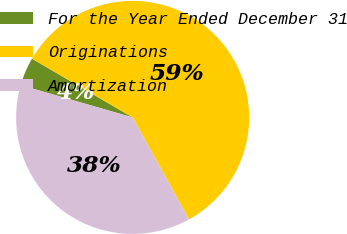<chart> <loc_0><loc_0><loc_500><loc_500><pie_chart><fcel>For the Year Ended December 31<fcel>Originations<fcel>Amortization<nl><fcel>3.94%<fcel>58.55%<fcel>37.5%<nl></chart> 